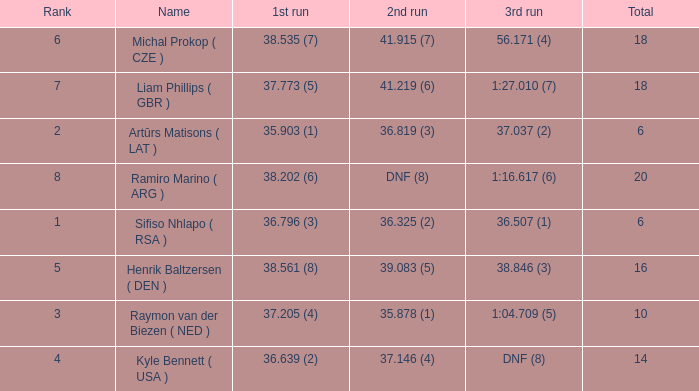Which average rank has a total of 16? 5.0. 